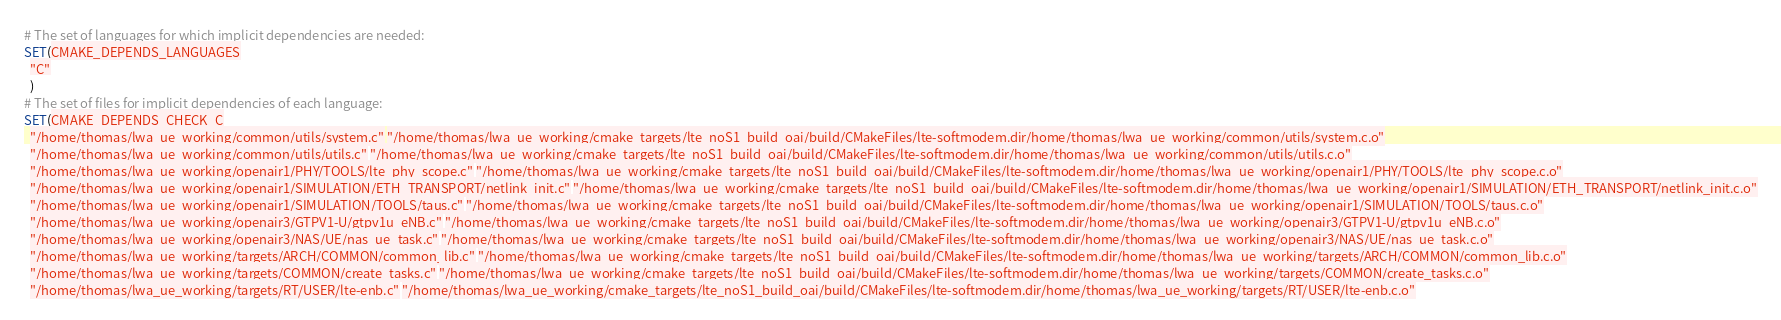Convert code to text. <code><loc_0><loc_0><loc_500><loc_500><_CMake_># The set of languages for which implicit dependencies are needed:
SET(CMAKE_DEPENDS_LANGUAGES
  "C"
  )
# The set of files for implicit dependencies of each language:
SET(CMAKE_DEPENDS_CHECK_C
  "/home/thomas/lwa_ue_working/common/utils/system.c" "/home/thomas/lwa_ue_working/cmake_targets/lte_noS1_build_oai/build/CMakeFiles/lte-softmodem.dir/home/thomas/lwa_ue_working/common/utils/system.c.o"
  "/home/thomas/lwa_ue_working/common/utils/utils.c" "/home/thomas/lwa_ue_working/cmake_targets/lte_noS1_build_oai/build/CMakeFiles/lte-softmodem.dir/home/thomas/lwa_ue_working/common/utils/utils.c.o"
  "/home/thomas/lwa_ue_working/openair1/PHY/TOOLS/lte_phy_scope.c" "/home/thomas/lwa_ue_working/cmake_targets/lte_noS1_build_oai/build/CMakeFiles/lte-softmodem.dir/home/thomas/lwa_ue_working/openair1/PHY/TOOLS/lte_phy_scope.c.o"
  "/home/thomas/lwa_ue_working/openair1/SIMULATION/ETH_TRANSPORT/netlink_init.c" "/home/thomas/lwa_ue_working/cmake_targets/lte_noS1_build_oai/build/CMakeFiles/lte-softmodem.dir/home/thomas/lwa_ue_working/openair1/SIMULATION/ETH_TRANSPORT/netlink_init.c.o"
  "/home/thomas/lwa_ue_working/openair1/SIMULATION/TOOLS/taus.c" "/home/thomas/lwa_ue_working/cmake_targets/lte_noS1_build_oai/build/CMakeFiles/lte-softmodem.dir/home/thomas/lwa_ue_working/openair1/SIMULATION/TOOLS/taus.c.o"
  "/home/thomas/lwa_ue_working/openair3/GTPV1-U/gtpv1u_eNB.c" "/home/thomas/lwa_ue_working/cmake_targets/lte_noS1_build_oai/build/CMakeFiles/lte-softmodem.dir/home/thomas/lwa_ue_working/openair3/GTPV1-U/gtpv1u_eNB.c.o"
  "/home/thomas/lwa_ue_working/openair3/NAS/UE/nas_ue_task.c" "/home/thomas/lwa_ue_working/cmake_targets/lte_noS1_build_oai/build/CMakeFiles/lte-softmodem.dir/home/thomas/lwa_ue_working/openair3/NAS/UE/nas_ue_task.c.o"
  "/home/thomas/lwa_ue_working/targets/ARCH/COMMON/common_lib.c" "/home/thomas/lwa_ue_working/cmake_targets/lte_noS1_build_oai/build/CMakeFiles/lte-softmodem.dir/home/thomas/lwa_ue_working/targets/ARCH/COMMON/common_lib.c.o"
  "/home/thomas/lwa_ue_working/targets/COMMON/create_tasks.c" "/home/thomas/lwa_ue_working/cmake_targets/lte_noS1_build_oai/build/CMakeFiles/lte-softmodem.dir/home/thomas/lwa_ue_working/targets/COMMON/create_tasks.c.o"
  "/home/thomas/lwa_ue_working/targets/RT/USER/lte-enb.c" "/home/thomas/lwa_ue_working/cmake_targets/lte_noS1_build_oai/build/CMakeFiles/lte-softmodem.dir/home/thomas/lwa_ue_working/targets/RT/USER/lte-enb.c.o"</code> 